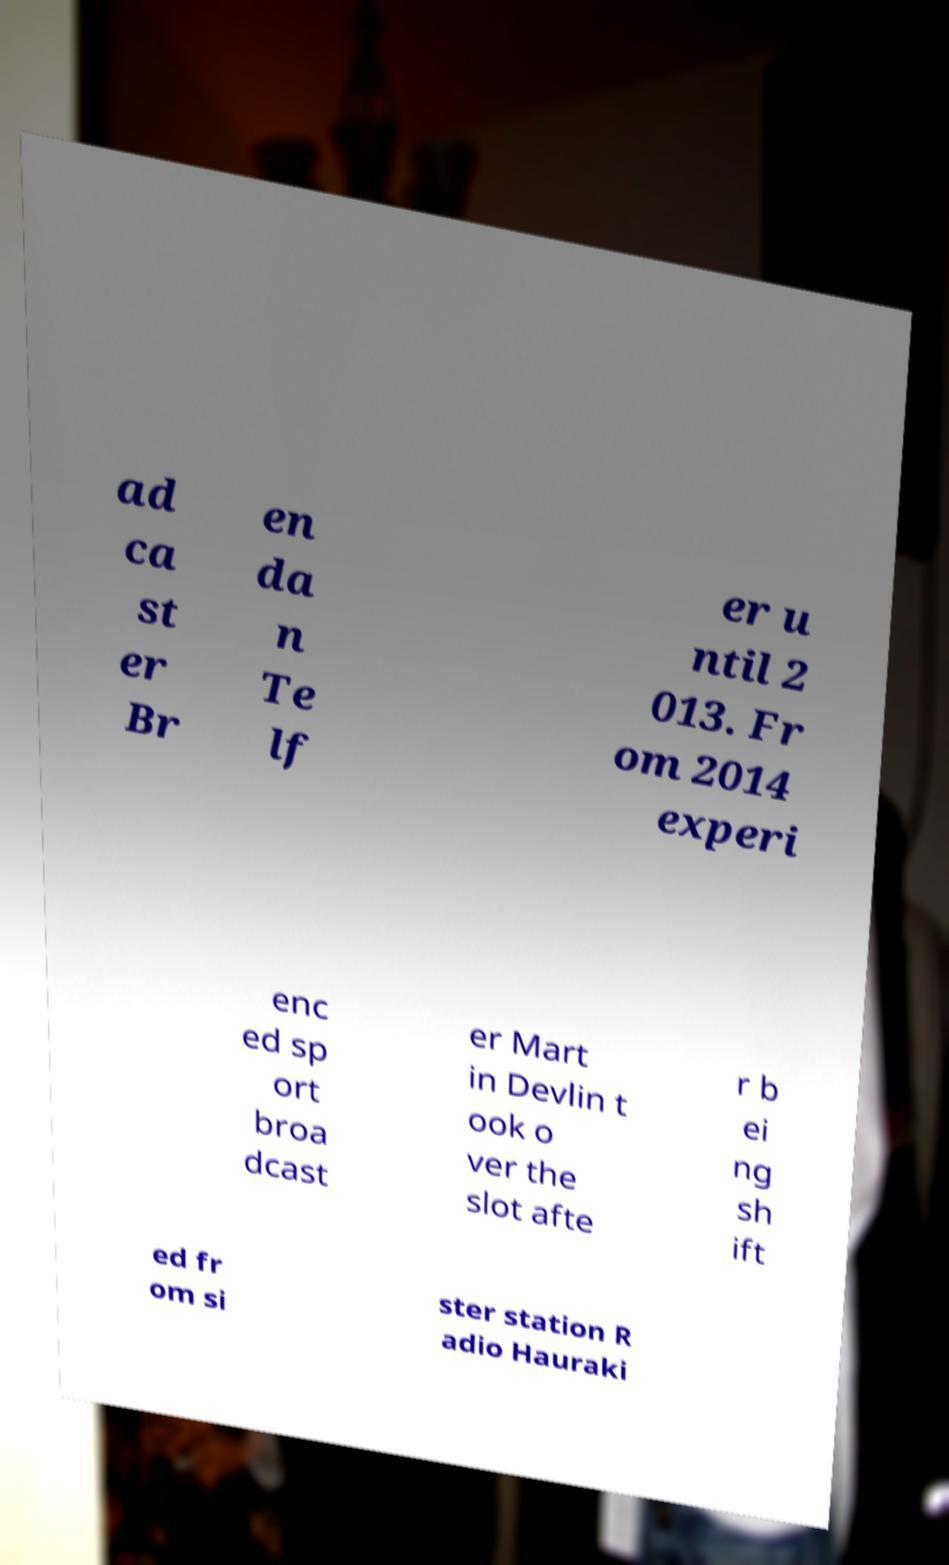Please identify and transcribe the text found in this image. ad ca st er Br en da n Te lf er u ntil 2 013. Fr om 2014 experi enc ed sp ort broa dcast er Mart in Devlin t ook o ver the slot afte r b ei ng sh ift ed fr om si ster station R adio Hauraki 